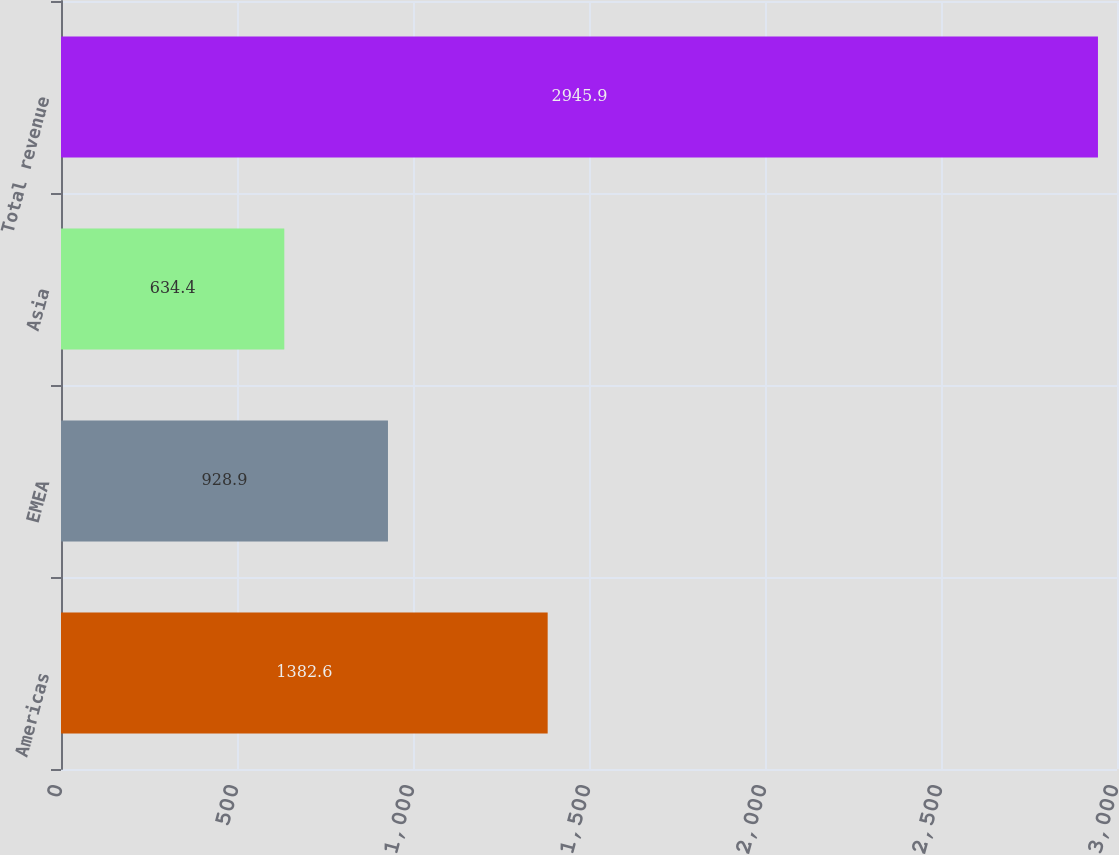Convert chart to OTSL. <chart><loc_0><loc_0><loc_500><loc_500><bar_chart><fcel>Americas<fcel>EMEA<fcel>Asia<fcel>Total revenue<nl><fcel>1382.6<fcel>928.9<fcel>634.4<fcel>2945.9<nl></chart> 